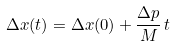Convert formula to latex. <formula><loc_0><loc_0><loc_500><loc_500>\Delta x ( t ) = \Delta x ( 0 ) + \frac { \Delta p } { M } \, t</formula> 